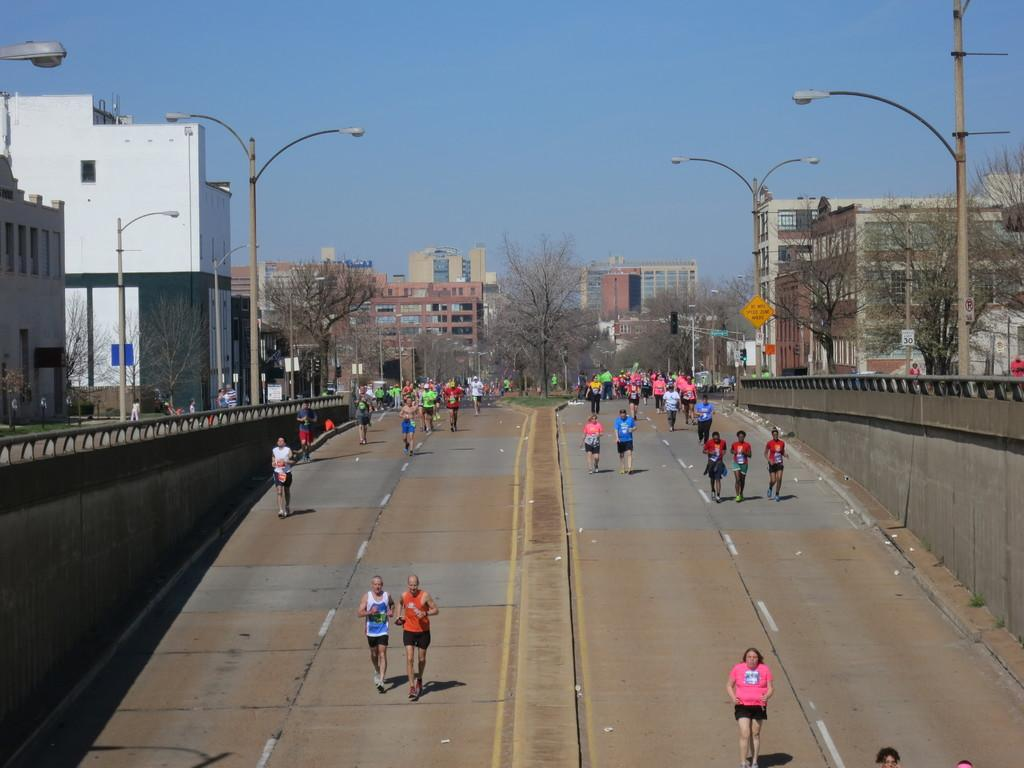What are the people in the image doing? The people in the image are walking on the roadside. What can be seen in the background of the image? There are trees visible in the image. What type of structures are present in the image? There are buildings in the image. What type of lock can be seen on the tree in the image? There is no lock present on any tree in the image. Can you see an owl perched on the building in the image? There is no owl visible in the image. 